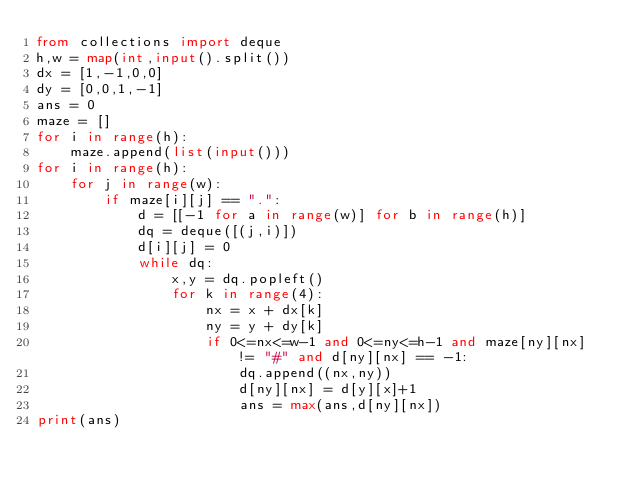Convert code to text. <code><loc_0><loc_0><loc_500><loc_500><_Python_>from collections import deque
h,w = map(int,input().split())
dx = [1,-1,0,0]
dy = [0,0,1,-1]
ans = 0
maze = []
for i in range(h):
    maze.append(list(input()))
for i in range(h):
    for j in range(w):
        if maze[i][j] == ".":
            d = [[-1 for a in range(w)] for b in range(h)]
            dq = deque([(j,i)])
            d[i][j] = 0
            while dq:
                x,y = dq.popleft()
                for k in range(4):
                    nx = x + dx[k]
                    ny = y + dy[k]
                    if 0<=nx<=w-1 and 0<=ny<=h-1 and maze[ny][nx] != "#" and d[ny][nx] == -1:
                        dq.append((nx,ny))
                        d[ny][nx] = d[y][x]+1
                        ans = max(ans,d[ny][nx])
print(ans)</code> 